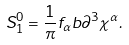<formula> <loc_0><loc_0><loc_500><loc_500>S _ { 1 } ^ { 0 } = \frac { 1 } { \pi } f _ { \alpha } b \partial ^ { 3 } \chi ^ { \alpha } .</formula> 